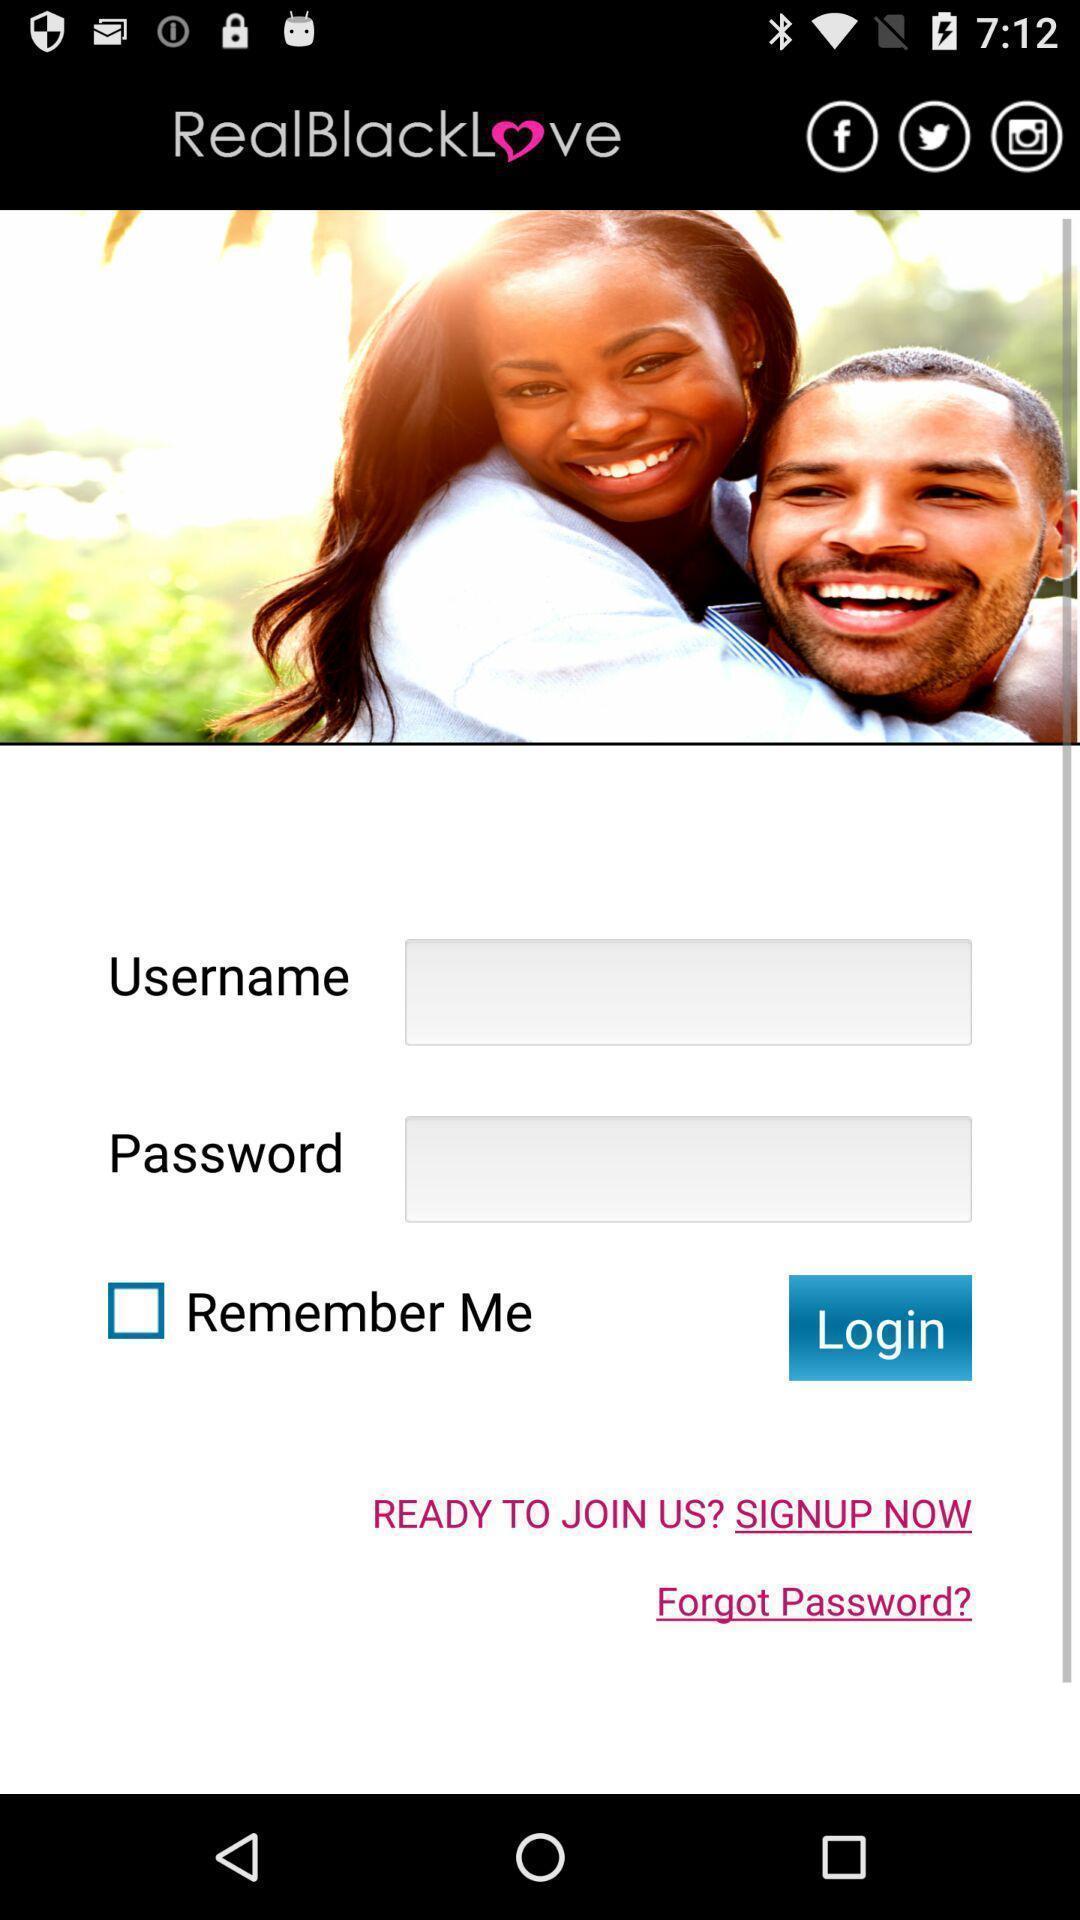Tell me about the visual elements in this screen capture. Page requesting to enter login credentials on a social app. 